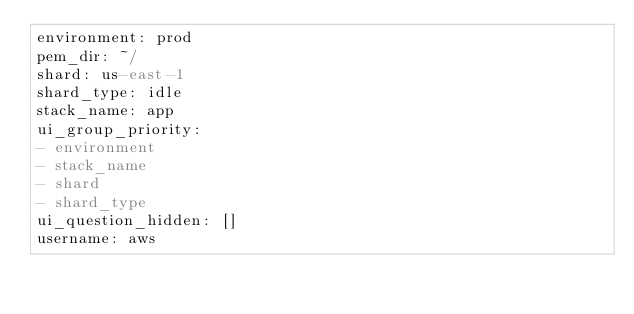Convert code to text. <code><loc_0><loc_0><loc_500><loc_500><_YAML_>environment: prod
pem_dir: ~/
shard: us-east-1
shard_type: idle
stack_name: app
ui_group_priority:
- environment
- stack_name
- shard
- shard_type
ui_question_hidden: []
username: aws
</code> 